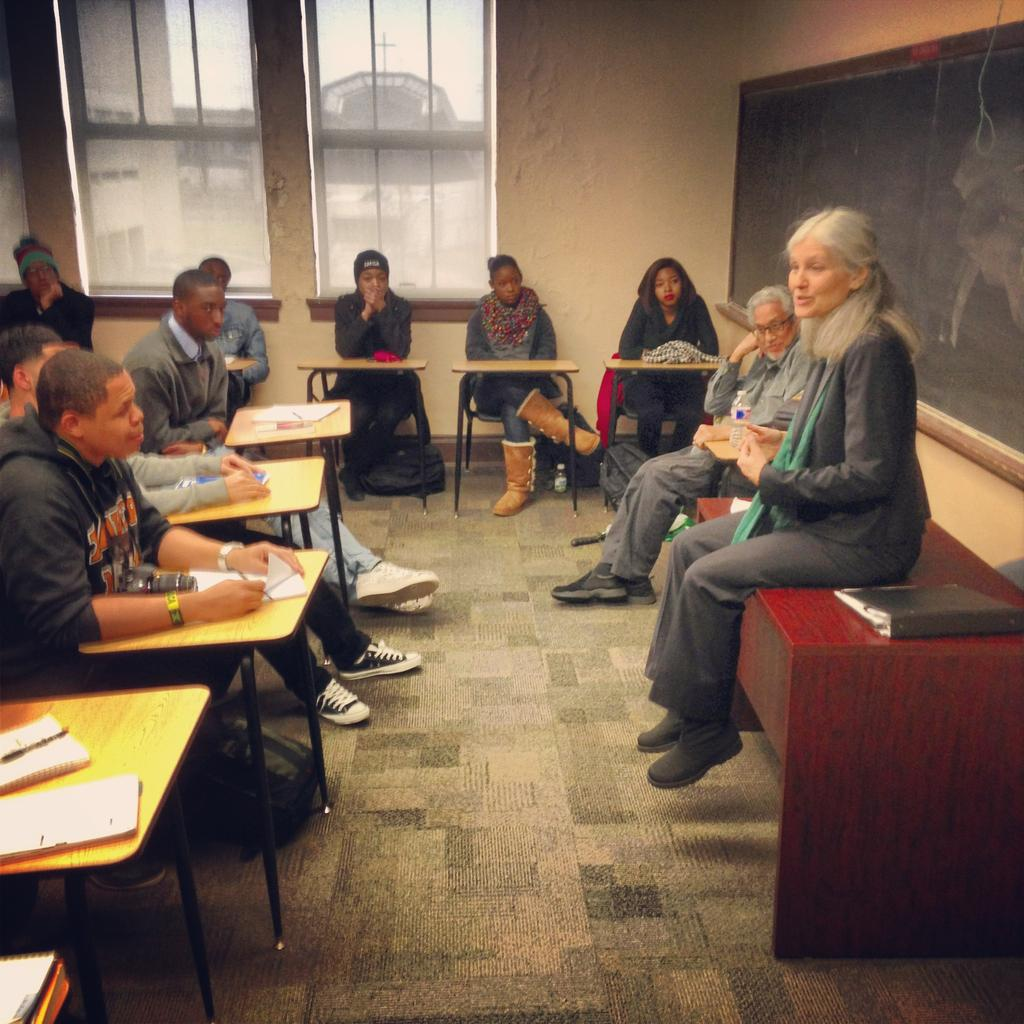What are the people in the image doing? The people in the image are sitting on chairs. Can you describe the lady's position in the image? There is a lady sitting on a desk in the image. What type of pie is the lady eating in the image? There is no pie present in the image; the lady is sitting on a desk. Can you hear the whistle in the image? There is no whistle present in the image, so it cannot be heard. 